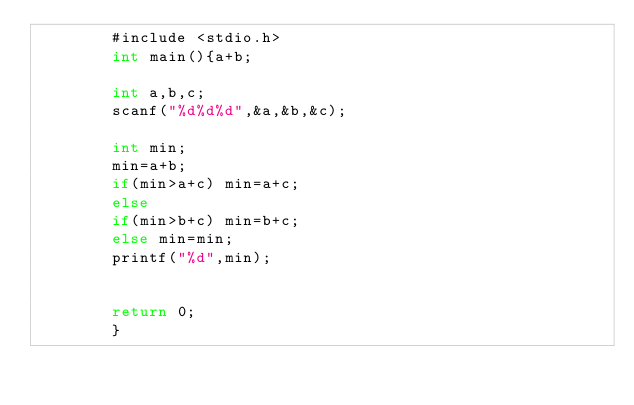<code> <loc_0><loc_0><loc_500><loc_500><_C_>        #include <stdio.h>
        int main(){a+b;
         
        int a,b,c;
        scanf("%d%d%d",&a,&b,&c);
         
        int min;
        min=a+b; 
        if(min>a+c) min=a+c;
        else 
        if(min>b+c) min=b+c;
        else min=min;
        printf("%d",min);
         
         
        return 0;  
        }</code> 